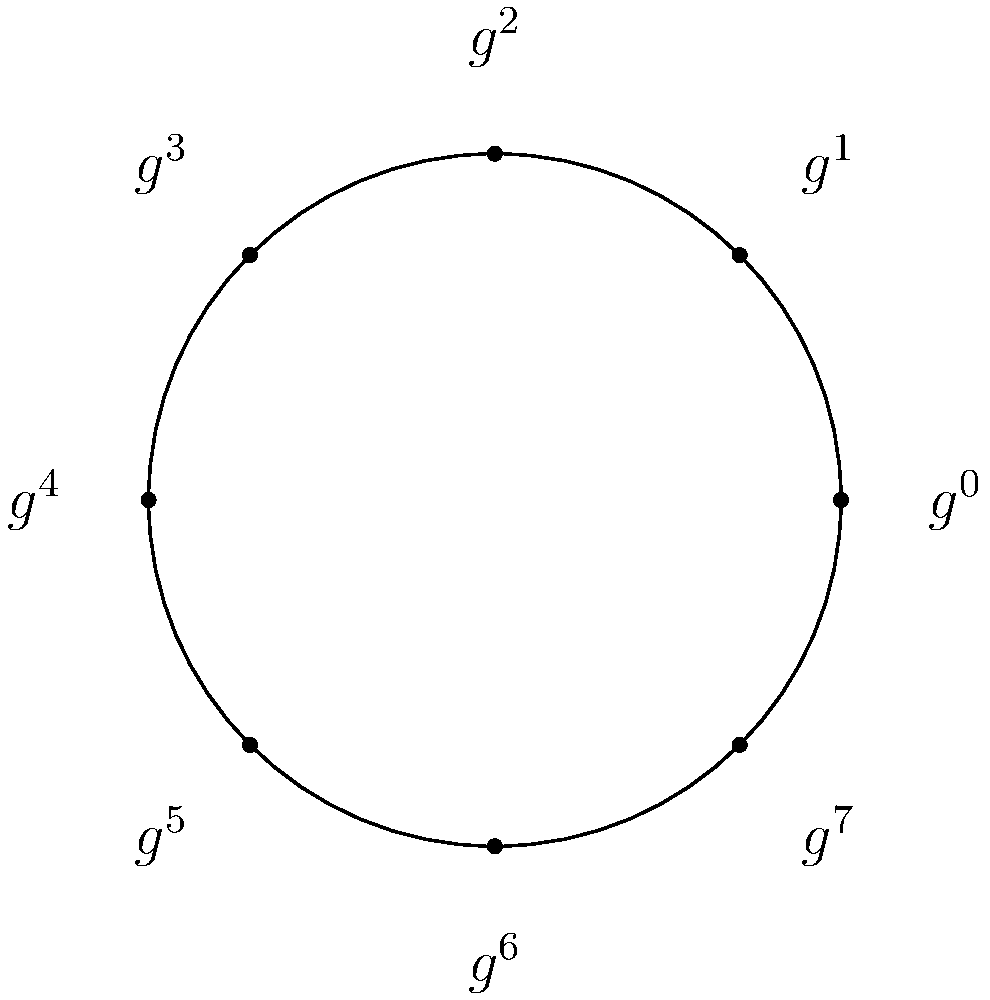In the cyclic group $C_8$ represented by the circular diagram, what is the order of the element $g^3$? To determine the order of $g^3$ in $C_8$, we need to follow these steps:

1) Recall that in a cyclic group of order 8, $g$ is a generator and $g^8 = e$ (the identity element).

2) The order of an element is the smallest positive integer $k$ such that $(g^3)^k = e$.

3) Let's compute the powers of $g^3$:
   $(g^3)^1 = g^3$
   $(g^3)^2 = g^6$
   $(g^3)^3 = g^9 = g^1$ (since $g^8 = e$)
   $(g^3)^4 = g^{12} = g^4$
   $(g^3)^5 = g^{15} = g^7$
   $(g^3)^6 = g^{18} = g^2$
   $(g^3)^7 = g^{21} = g^5$
   $(g^3)^8 = g^{24} = e$

4) We see that $(g^3)^8 = e$, and this is the smallest positive integer $k$ for which this equality holds.

Therefore, the order of $g^3$ is 8.
Answer: 8 